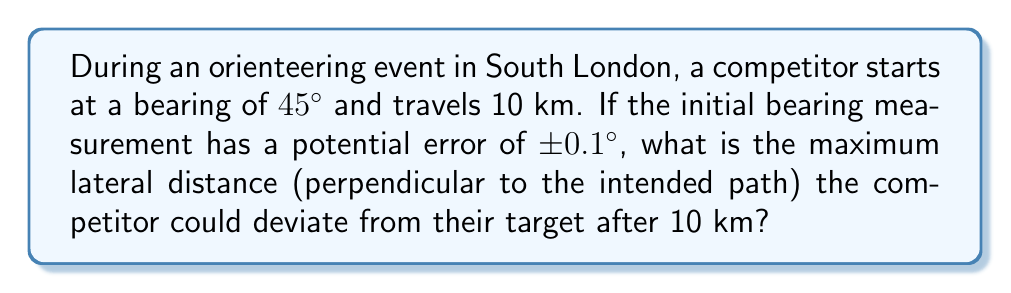Could you help me with this problem? To solve this problem, we need to consider the sensitivity to initial conditions in compass bearings over long distances. Let's approach this step-by-step:

1) First, we need to understand that a small error in the initial bearing can lead to a significant deviation over a long distance. This is a key concept in chaos theory.

2) The maximum deviation will occur when the error is at its maximum, which is 0.1° in either direction.

3) We can treat this as a right-angled triangle problem, where:
   - The hypotenuse is the 10 km travel distance
   - The angle between the intended path and the actual path is 0.1°
   - We need to find the opposite side of this triangle

4) To find the lateral distance (opposite side), we can use the sine function:

   $\sin(\theta) = \frac{\text{opposite}}{\text{hypotenuse}}$

5) Rearranging this, we get:

   $\text{opposite} = \sin(\theta) \times \text{hypotenuse}$

6) Plugging in our values:

   $\text{lateral distance} = \sin(0.1°) \times 10\text{ km}$

7) Using a calculator (as sine of such a small angle is very small):

   $\sin(0.1°) \approx 0.001745$

8) Therefore:

   $\text{lateral distance} \approx 0.001745 \times 10\text{ km} = 0.01745\text{ km} = 17.45\text{ m}$

This demonstrates how a tiny error in initial bearing can result in a noticeable deviation over a long distance, illustrating the sensitivity to initial conditions.
Answer: 17.45 m 